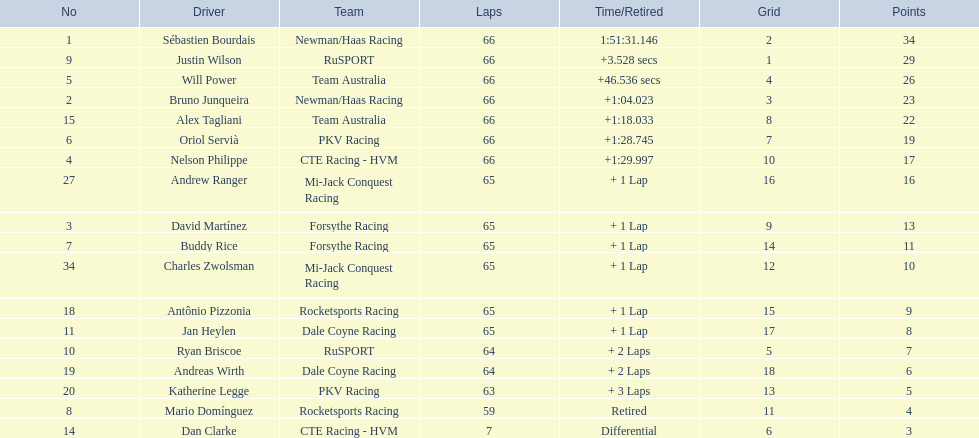Which teams participated in the 2006 gran premio telmex? Newman/Haas Racing, RuSPORT, Team Australia, Newman/Haas Racing, Team Australia, PKV Racing, CTE Racing - HVM, Mi-Jack Conquest Racing, Forsythe Racing, Forsythe Racing, Mi-Jack Conquest Racing, Rocketsports Racing, Dale Coyne Racing, RuSPORT, Dale Coyne Racing, PKV Racing, Rocketsports Racing, CTE Racing - HVM. Who were the drivers of these teams? Sébastien Bourdais, Justin Wilson, Will Power, Bruno Junqueira, Alex Tagliani, Oriol Servià, Nelson Philippe, Andrew Ranger, David Martínez, Buddy Rice, Charles Zwolsman, Antônio Pizzonia, Jan Heylen, Ryan Briscoe, Andreas Wirth, Katherine Legge, Mario Domínguez, Dan Clarke. Which driver finished last? Dan Clarke. 